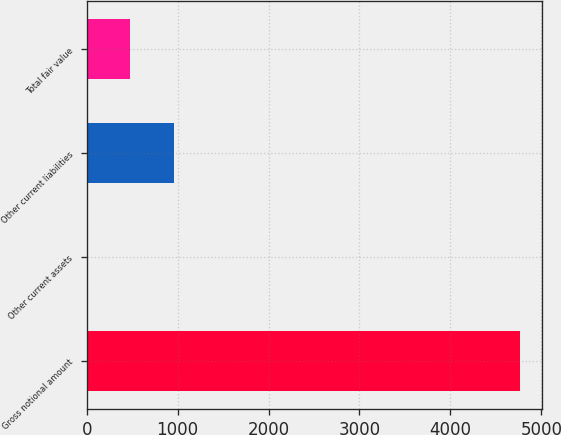Convert chart. <chart><loc_0><loc_0><loc_500><loc_500><bar_chart><fcel>Gross notional amount<fcel>Other current assets<fcel>Other current liabilities<fcel>Total fair value<nl><fcel>4767<fcel>4<fcel>956.6<fcel>480.3<nl></chart> 